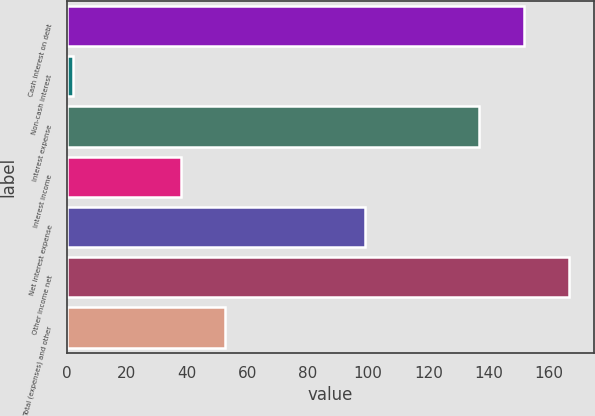Convert chart. <chart><loc_0><loc_0><loc_500><loc_500><bar_chart><fcel>Cash interest on debt<fcel>Non-cash interest<fcel>Interest expense<fcel>Interest income<fcel>Net interest expense<fcel>Other income net<fcel>Total (expenses) and other<nl><fcel>151.61<fcel>2.1<fcel>136.8<fcel>37.8<fcel>99<fcel>166.42<fcel>52.61<nl></chart> 